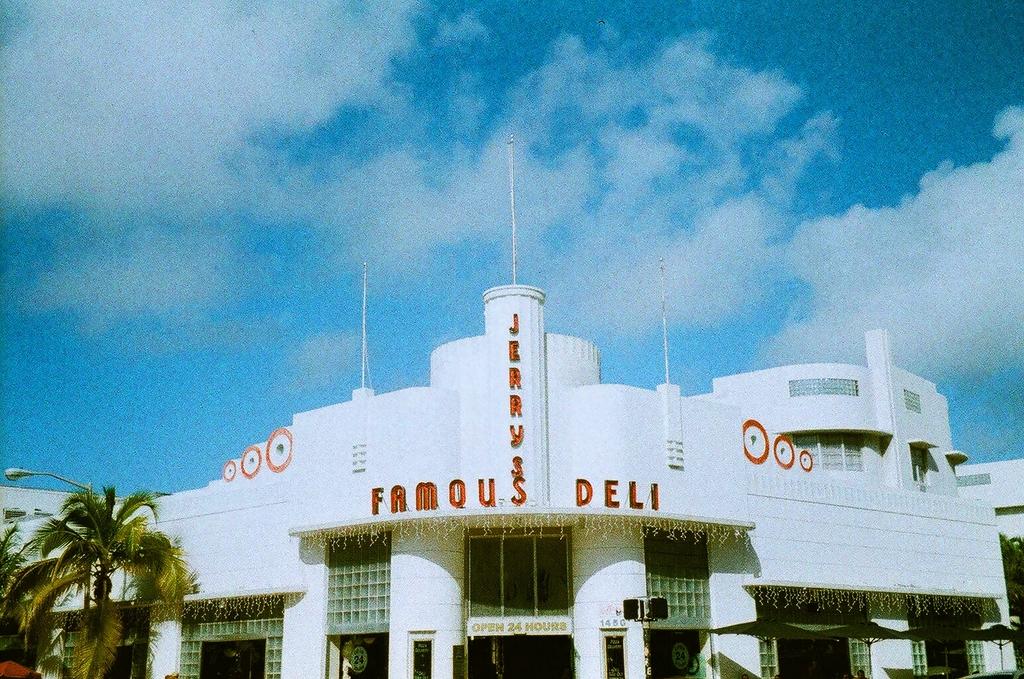What are the words on the building?
Make the answer very short. Jerry's famous deli. 